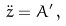Convert formula to latex. <formula><loc_0><loc_0><loc_500><loc_500>\ddot { z } = A ^ { \prime } \, ,</formula> 